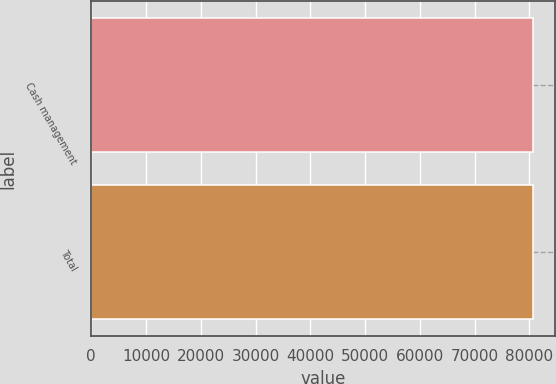<chart> <loc_0><loc_0><loc_500><loc_500><bar_chart><fcel>Cash management<fcel>Total<nl><fcel>80635<fcel>80635.1<nl></chart> 